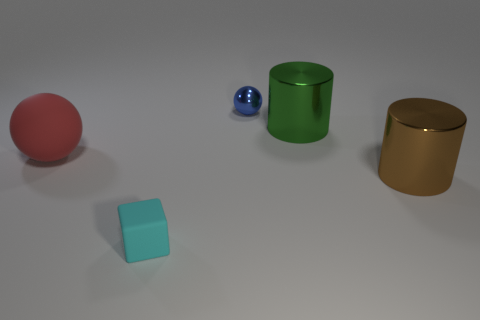Is there any other thing that is the same shape as the small cyan matte object?
Keep it short and to the point. No. Is the number of small spheres behind the blue metal sphere less than the number of red objects to the right of the rubber ball?
Keep it short and to the point. No. What number of cylinders are the same color as the tiny shiny thing?
Give a very brief answer. 0. What number of tiny things are both behind the large ball and in front of the large brown cylinder?
Offer a very short reply. 0. There is a large thing that is to the left of the tiny object behind the big green object; what is its material?
Provide a succinct answer. Rubber. Is there a sphere made of the same material as the tiny cyan cube?
Provide a short and direct response. Yes. There is a ball that is the same size as the green metal cylinder; what is its material?
Your response must be concise. Rubber. There is a sphere to the left of the object behind the cylinder that is behind the big brown cylinder; what size is it?
Your answer should be compact. Large. There is a large shiny cylinder that is to the left of the brown cylinder; are there any red things to the left of it?
Provide a succinct answer. Yes. Is the shape of the green metal object the same as the metallic object that is in front of the red matte thing?
Offer a terse response. Yes. 